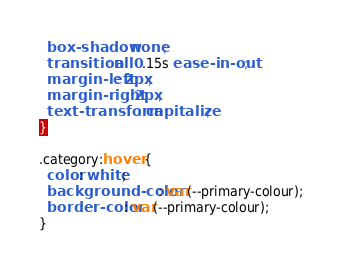<code> <loc_0><loc_0><loc_500><loc_500><_CSS_>  box-shadow: none;
  transition: all 0.15s ease-in-out;
  margin-left: 2px;
  margin-right: 2px;
  text-transform: capitalize;
}

.category:hover {
  color: white;
  background-color: var(--primary-colour);
  border-color: var(--primary-colour);
}
</code> 